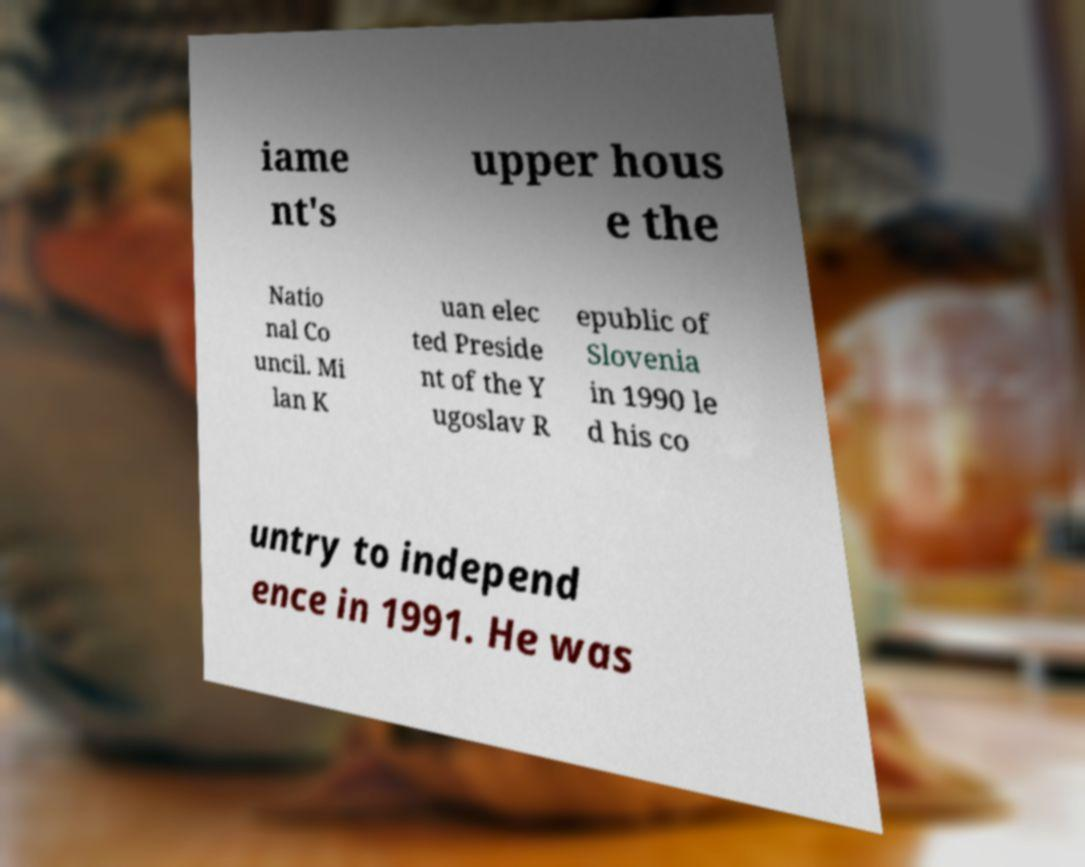Please read and relay the text visible in this image. What does it say? iame nt's upper hous e the Natio nal Co uncil. Mi lan K uan elec ted Preside nt of the Y ugoslav R epublic of Slovenia in 1990 le d his co untry to independ ence in 1991. He was 